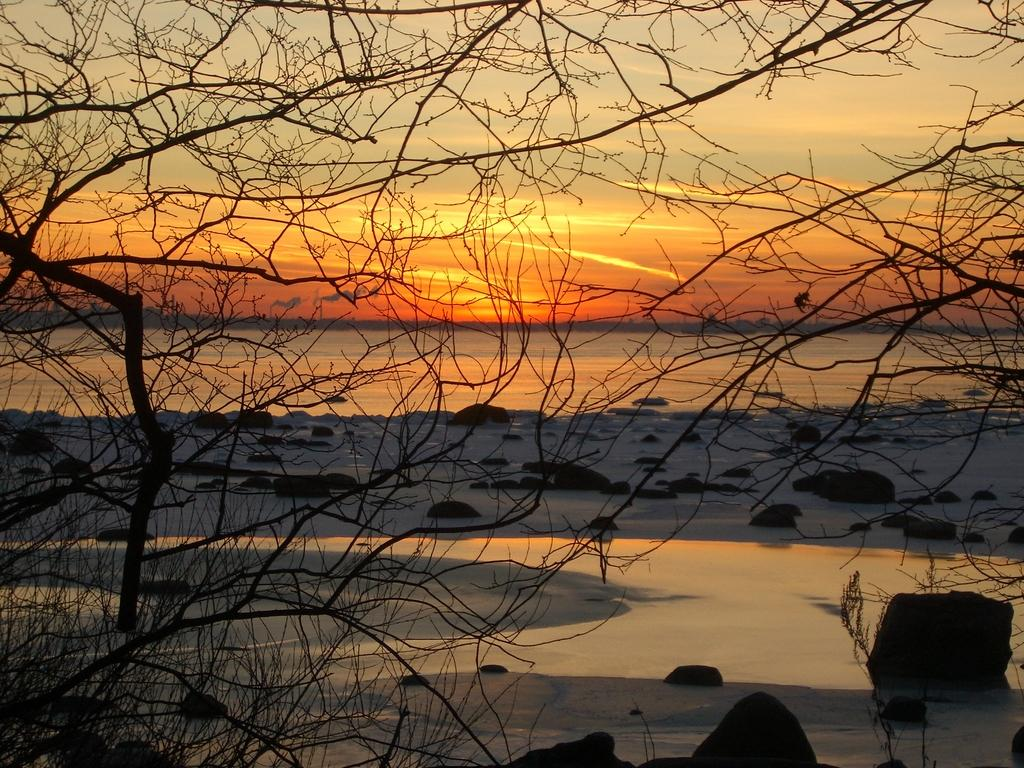What type of natural elements can be seen in the image? There are trees and water visible in the image. What other objects can be found in the image? There are rocks in the image. What is the source of light in the image? Sunlight is present in the image. What can be seen in the background of the image? The sky is visible in the background of the image. Where is the drawer located in the image? There is no drawer present in the image. What type of trees can be seen in the image? The provided facts do not specify the type of trees; they only mention that there are trees in the image. 